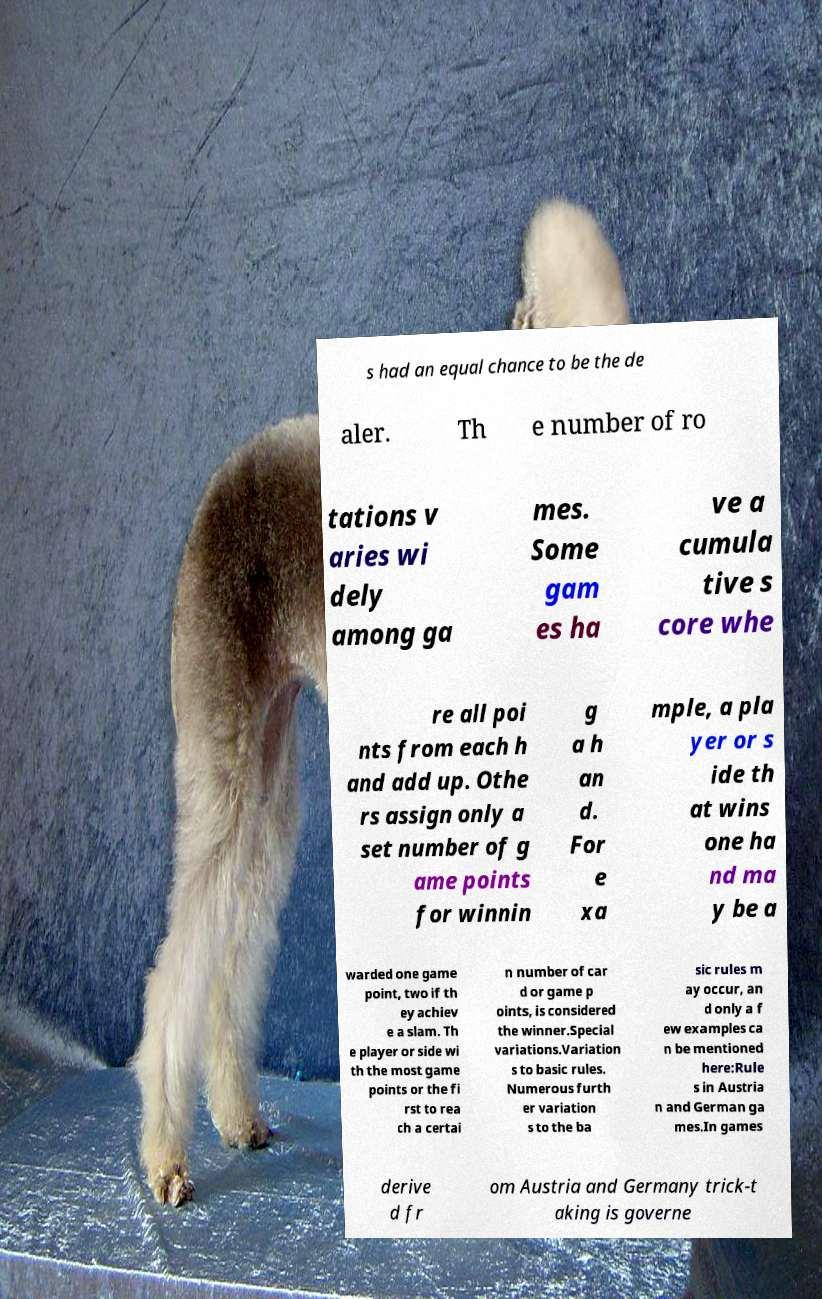Could you assist in decoding the text presented in this image and type it out clearly? s had an equal chance to be the de aler. Th e number of ro tations v aries wi dely among ga mes. Some gam es ha ve a cumula tive s core whe re all poi nts from each h and add up. Othe rs assign only a set number of g ame points for winnin g a h an d. For e xa mple, a pla yer or s ide th at wins one ha nd ma y be a warded one game point, two if th ey achiev e a slam. Th e player or side wi th the most game points or the fi rst to rea ch a certai n number of car d or game p oints, is considered the winner.Special variations.Variation s to basic rules. Numerous furth er variation s to the ba sic rules m ay occur, an d only a f ew examples ca n be mentioned here:Rule s in Austria n and German ga mes.In games derive d fr om Austria and Germany trick-t aking is governe 